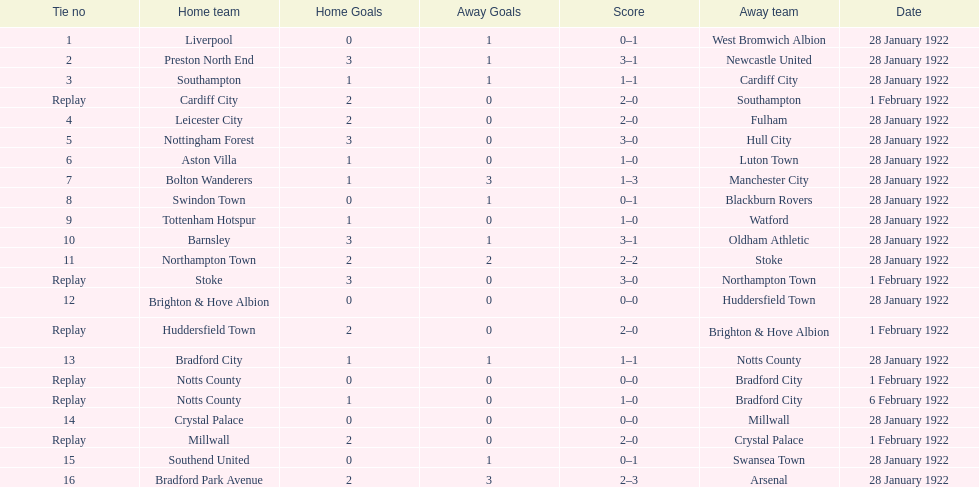What is the number of points scored on 6 february 1922? 1. 